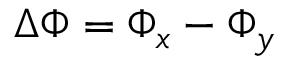<formula> <loc_0><loc_0><loc_500><loc_500>\Delta \Phi = \Phi _ { x } - \Phi _ { y }</formula> 